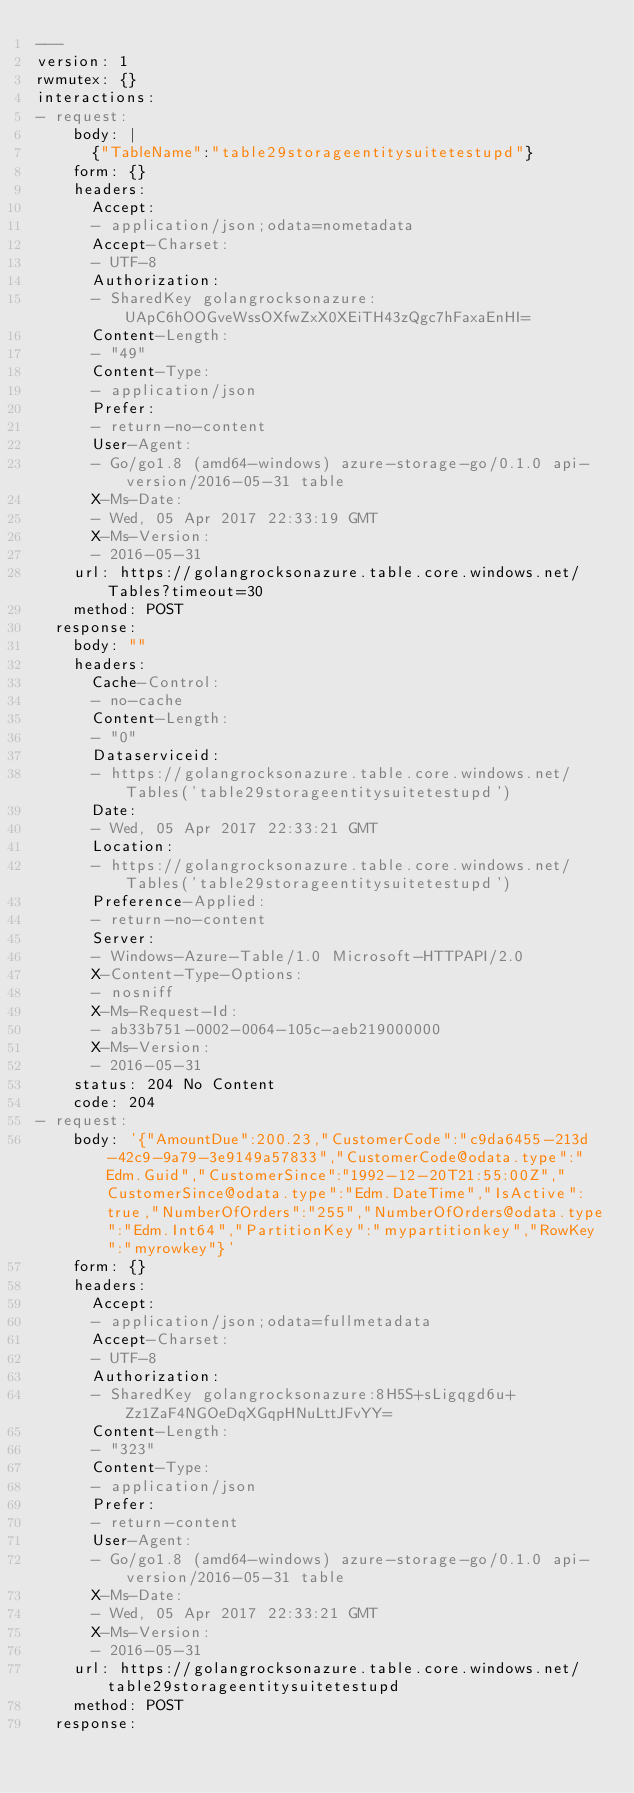Convert code to text. <code><loc_0><loc_0><loc_500><loc_500><_YAML_>---
version: 1
rwmutex: {}
interactions:
- request:
    body: |
      {"TableName":"table29storageentitysuitetestupd"}
    form: {}
    headers:
      Accept:
      - application/json;odata=nometadata
      Accept-Charset:
      - UTF-8
      Authorization:
      - SharedKey golangrocksonazure:UApC6hOOGveWssOXfwZxX0XEiTH43zQgc7hFaxaEnHI=
      Content-Length:
      - "49"
      Content-Type:
      - application/json
      Prefer:
      - return-no-content
      User-Agent:
      - Go/go1.8 (amd64-windows) azure-storage-go/0.1.0 api-version/2016-05-31 table
      X-Ms-Date:
      - Wed, 05 Apr 2017 22:33:19 GMT
      X-Ms-Version:
      - 2016-05-31
    url: https://golangrocksonazure.table.core.windows.net/Tables?timeout=30
    method: POST
  response:
    body: ""
    headers:
      Cache-Control:
      - no-cache
      Content-Length:
      - "0"
      Dataserviceid:
      - https://golangrocksonazure.table.core.windows.net/Tables('table29storageentitysuitetestupd')
      Date:
      - Wed, 05 Apr 2017 22:33:21 GMT
      Location:
      - https://golangrocksonazure.table.core.windows.net/Tables('table29storageentitysuitetestupd')
      Preference-Applied:
      - return-no-content
      Server:
      - Windows-Azure-Table/1.0 Microsoft-HTTPAPI/2.0
      X-Content-Type-Options:
      - nosniff
      X-Ms-Request-Id:
      - ab33b751-0002-0064-105c-aeb219000000
      X-Ms-Version:
      - 2016-05-31
    status: 204 No Content
    code: 204
- request:
    body: '{"AmountDue":200.23,"CustomerCode":"c9da6455-213d-42c9-9a79-3e9149a57833","CustomerCode@odata.type":"Edm.Guid","CustomerSince":"1992-12-20T21:55:00Z","CustomerSince@odata.type":"Edm.DateTime","IsActive":true,"NumberOfOrders":"255","NumberOfOrders@odata.type":"Edm.Int64","PartitionKey":"mypartitionkey","RowKey":"myrowkey"}'
    form: {}
    headers:
      Accept:
      - application/json;odata=fullmetadata
      Accept-Charset:
      - UTF-8
      Authorization:
      - SharedKey golangrocksonazure:8H5S+sLigqgd6u+Zz1ZaF4NGOeDqXGqpHNuLttJFvYY=
      Content-Length:
      - "323"
      Content-Type:
      - application/json
      Prefer:
      - return-content
      User-Agent:
      - Go/go1.8 (amd64-windows) azure-storage-go/0.1.0 api-version/2016-05-31 table
      X-Ms-Date:
      - Wed, 05 Apr 2017 22:33:21 GMT
      X-Ms-Version:
      - 2016-05-31
    url: https://golangrocksonazure.table.core.windows.net/table29storageentitysuitetestupd
    method: POST
  response:</code> 